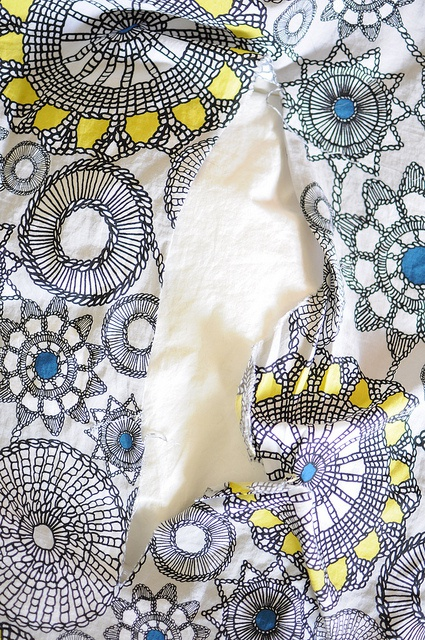Describe the objects in this image and their specific colors. I can see a bed in lightgray, black, darkgray, gray, and beige tones in this image. 